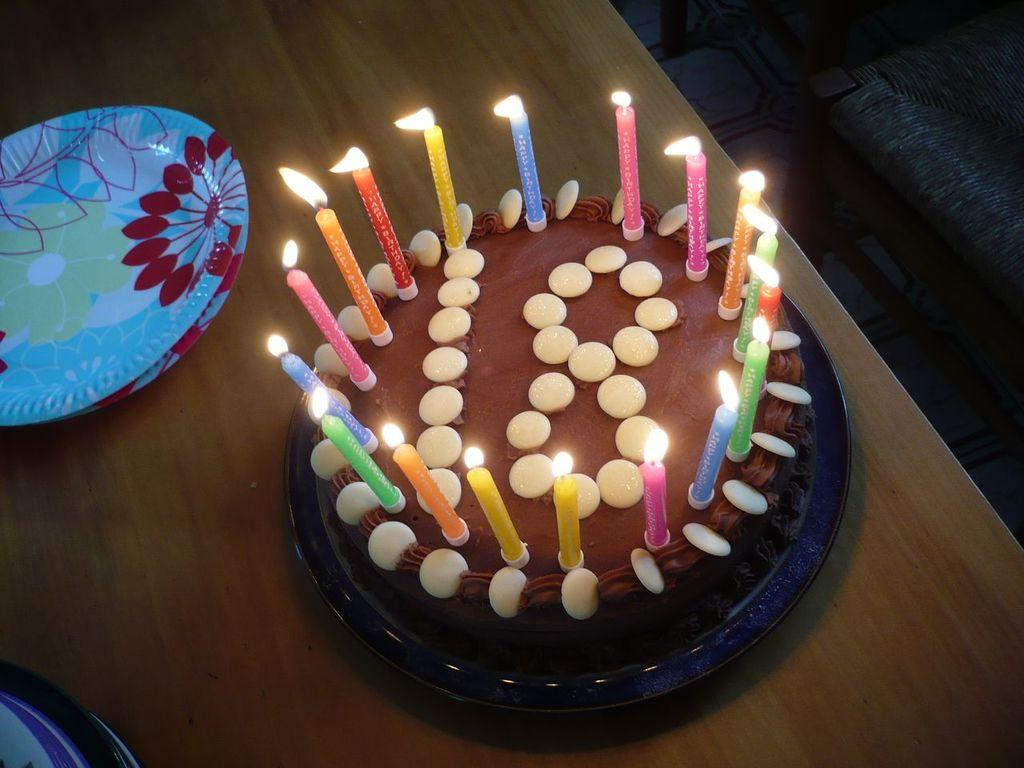What is the main subject of the image? There is a cake in the image. What is a notable feature of the cake? The cake has candles. What is a characteristic of the candles? There is a flame on the candles. What can be seen on the wooden table? There are two plates on the wooden table. What type of government is depicted in the image? There is no depiction of a government in the image; it features a cake with candles and two plates on a wooden table. What emotion is being expressed by the cake in the image? The cake is an inanimate object and does not express emotions. 